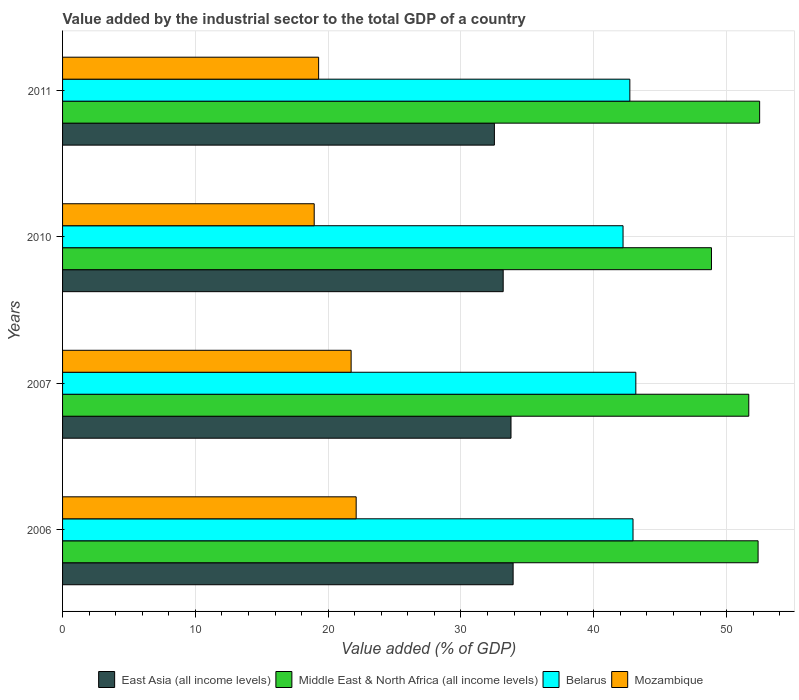How many different coloured bars are there?
Your response must be concise. 4. Are the number of bars per tick equal to the number of legend labels?
Your answer should be very brief. Yes. Are the number of bars on each tick of the Y-axis equal?
Make the answer very short. Yes. What is the label of the 1st group of bars from the top?
Keep it short and to the point. 2011. What is the value added by the industrial sector to the total GDP in Middle East & North Africa (all income levels) in 2010?
Keep it short and to the point. 48.86. Across all years, what is the maximum value added by the industrial sector to the total GDP in Middle East & North Africa (all income levels)?
Offer a terse response. 52.49. Across all years, what is the minimum value added by the industrial sector to the total GDP in Mozambique?
Make the answer very short. 18.95. What is the total value added by the industrial sector to the total GDP in Belarus in the graph?
Your answer should be compact. 171.04. What is the difference between the value added by the industrial sector to the total GDP in Belarus in 2006 and that in 2011?
Your response must be concise. 0.24. What is the difference between the value added by the industrial sector to the total GDP in Mozambique in 2010 and the value added by the industrial sector to the total GDP in Belarus in 2011?
Your answer should be compact. -23.77. What is the average value added by the industrial sector to the total GDP in Belarus per year?
Ensure brevity in your answer.  42.76. In the year 2007, what is the difference between the value added by the industrial sector to the total GDP in Middle East & North Africa (all income levels) and value added by the industrial sector to the total GDP in Mozambique?
Provide a succinct answer. 29.94. What is the ratio of the value added by the industrial sector to the total GDP in Belarus in 2010 to that in 2011?
Give a very brief answer. 0.99. Is the value added by the industrial sector to the total GDP in Belarus in 2007 less than that in 2010?
Offer a very short reply. No. What is the difference between the highest and the second highest value added by the industrial sector to the total GDP in East Asia (all income levels)?
Your response must be concise. 0.16. What is the difference between the highest and the lowest value added by the industrial sector to the total GDP in Mozambique?
Give a very brief answer. 3.16. Is the sum of the value added by the industrial sector to the total GDP in Belarus in 2007 and 2010 greater than the maximum value added by the industrial sector to the total GDP in East Asia (all income levels) across all years?
Offer a terse response. Yes. What does the 4th bar from the top in 2010 represents?
Ensure brevity in your answer.  East Asia (all income levels). What does the 1st bar from the bottom in 2011 represents?
Make the answer very short. East Asia (all income levels). Is it the case that in every year, the sum of the value added by the industrial sector to the total GDP in Mozambique and value added by the industrial sector to the total GDP in Middle East & North Africa (all income levels) is greater than the value added by the industrial sector to the total GDP in East Asia (all income levels)?
Your answer should be compact. Yes. How many bars are there?
Your answer should be compact. 16. How many years are there in the graph?
Your answer should be compact. 4. Are the values on the major ticks of X-axis written in scientific E-notation?
Your response must be concise. No. Does the graph contain grids?
Your response must be concise. Yes. Where does the legend appear in the graph?
Ensure brevity in your answer.  Bottom center. How are the legend labels stacked?
Your answer should be very brief. Horizontal. What is the title of the graph?
Offer a terse response. Value added by the industrial sector to the total GDP of a country. Does "Comoros" appear as one of the legend labels in the graph?
Your response must be concise. No. What is the label or title of the X-axis?
Your answer should be very brief. Value added (% of GDP). What is the Value added (% of GDP) of East Asia (all income levels) in 2006?
Provide a succinct answer. 33.93. What is the Value added (% of GDP) in Middle East & North Africa (all income levels) in 2006?
Your answer should be very brief. 52.37. What is the Value added (% of GDP) in Belarus in 2006?
Offer a very short reply. 42.95. What is the Value added (% of GDP) in Mozambique in 2006?
Your response must be concise. 22.11. What is the Value added (% of GDP) of East Asia (all income levels) in 2007?
Keep it short and to the point. 33.77. What is the Value added (% of GDP) of Middle East & North Africa (all income levels) in 2007?
Make the answer very short. 51.67. What is the Value added (% of GDP) in Belarus in 2007?
Make the answer very short. 43.17. What is the Value added (% of GDP) in Mozambique in 2007?
Your answer should be compact. 21.73. What is the Value added (% of GDP) in East Asia (all income levels) in 2010?
Provide a succinct answer. 33.18. What is the Value added (% of GDP) in Middle East & North Africa (all income levels) in 2010?
Keep it short and to the point. 48.86. What is the Value added (% of GDP) of Belarus in 2010?
Offer a terse response. 42.21. What is the Value added (% of GDP) of Mozambique in 2010?
Keep it short and to the point. 18.95. What is the Value added (% of GDP) of East Asia (all income levels) in 2011?
Make the answer very short. 32.52. What is the Value added (% of GDP) in Middle East & North Africa (all income levels) in 2011?
Ensure brevity in your answer.  52.49. What is the Value added (% of GDP) of Belarus in 2011?
Offer a very short reply. 42.72. What is the Value added (% of GDP) of Mozambique in 2011?
Your answer should be compact. 19.28. Across all years, what is the maximum Value added (% of GDP) in East Asia (all income levels)?
Your answer should be very brief. 33.93. Across all years, what is the maximum Value added (% of GDP) in Middle East & North Africa (all income levels)?
Provide a succinct answer. 52.49. Across all years, what is the maximum Value added (% of GDP) of Belarus?
Keep it short and to the point. 43.17. Across all years, what is the maximum Value added (% of GDP) of Mozambique?
Give a very brief answer. 22.11. Across all years, what is the minimum Value added (% of GDP) of East Asia (all income levels)?
Your answer should be compact. 32.52. Across all years, what is the minimum Value added (% of GDP) in Middle East & North Africa (all income levels)?
Give a very brief answer. 48.86. Across all years, what is the minimum Value added (% of GDP) of Belarus?
Provide a short and direct response. 42.21. Across all years, what is the minimum Value added (% of GDP) in Mozambique?
Make the answer very short. 18.95. What is the total Value added (% of GDP) in East Asia (all income levels) in the graph?
Offer a very short reply. 133.39. What is the total Value added (% of GDP) in Middle East & North Africa (all income levels) in the graph?
Provide a succinct answer. 205.4. What is the total Value added (% of GDP) in Belarus in the graph?
Give a very brief answer. 171.04. What is the total Value added (% of GDP) of Mozambique in the graph?
Offer a terse response. 82.07. What is the difference between the Value added (% of GDP) in East Asia (all income levels) in 2006 and that in 2007?
Offer a very short reply. 0.16. What is the difference between the Value added (% of GDP) in Middle East & North Africa (all income levels) in 2006 and that in 2007?
Ensure brevity in your answer.  0.7. What is the difference between the Value added (% of GDP) of Belarus in 2006 and that in 2007?
Your answer should be compact. -0.21. What is the difference between the Value added (% of GDP) in Mozambique in 2006 and that in 2007?
Offer a terse response. 0.38. What is the difference between the Value added (% of GDP) of East Asia (all income levels) in 2006 and that in 2010?
Keep it short and to the point. 0.75. What is the difference between the Value added (% of GDP) in Middle East & North Africa (all income levels) in 2006 and that in 2010?
Offer a terse response. 3.51. What is the difference between the Value added (% of GDP) in Belarus in 2006 and that in 2010?
Your answer should be compact. 0.75. What is the difference between the Value added (% of GDP) of Mozambique in 2006 and that in 2010?
Give a very brief answer. 3.16. What is the difference between the Value added (% of GDP) of East Asia (all income levels) in 2006 and that in 2011?
Give a very brief answer. 1.41. What is the difference between the Value added (% of GDP) of Middle East & North Africa (all income levels) in 2006 and that in 2011?
Your answer should be very brief. -0.12. What is the difference between the Value added (% of GDP) in Belarus in 2006 and that in 2011?
Your answer should be compact. 0.24. What is the difference between the Value added (% of GDP) in Mozambique in 2006 and that in 2011?
Make the answer very short. 2.83. What is the difference between the Value added (% of GDP) in East Asia (all income levels) in 2007 and that in 2010?
Your answer should be very brief. 0.59. What is the difference between the Value added (% of GDP) of Middle East & North Africa (all income levels) in 2007 and that in 2010?
Your answer should be compact. 2.81. What is the difference between the Value added (% of GDP) of Belarus in 2007 and that in 2010?
Give a very brief answer. 0.96. What is the difference between the Value added (% of GDP) in Mozambique in 2007 and that in 2010?
Offer a terse response. 2.78. What is the difference between the Value added (% of GDP) of East Asia (all income levels) in 2007 and that in 2011?
Make the answer very short. 1.25. What is the difference between the Value added (% of GDP) in Middle East & North Africa (all income levels) in 2007 and that in 2011?
Ensure brevity in your answer.  -0.82. What is the difference between the Value added (% of GDP) in Belarus in 2007 and that in 2011?
Give a very brief answer. 0.45. What is the difference between the Value added (% of GDP) of Mozambique in 2007 and that in 2011?
Provide a short and direct response. 2.45. What is the difference between the Value added (% of GDP) in East Asia (all income levels) in 2010 and that in 2011?
Your answer should be compact. 0.66. What is the difference between the Value added (% of GDP) of Middle East & North Africa (all income levels) in 2010 and that in 2011?
Give a very brief answer. -3.63. What is the difference between the Value added (% of GDP) of Belarus in 2010 and that in 2011?
Keep it short and to the point. -0.51. What is the difference between the Value added (% of GDP) of Mozambique in 2010 and that in 2011?
Keep it short and to the point. -0.33. What is the difference between the Value added (% of GDP) in East Asia (all income levels) in 2006 and the Value added (% of GDP) in Middle East & North Africa (all income levels) in 2007?
Make the answer very short. -17.75. What is the difference between the Value added (% of GDP) of East Asia (all income levels) in 2006 and the Value added (% of GDP) of Belarus in 2007?
Give a very brief answer. -9.24. What is the difference between the Value added (% of GDP) of East Asia (all income levels) in 2006 and the Value added (% of GDP) of Mozambique in 2007?
Provide a succinct answer. 12.2. What is the difference between the Value added (% of GDP) in Middle East & North Africa (all income levels) in 2006 and the Value added (% of GDP) in Belarus in 2007?
Your answer should be compact. 9.21. What is the difference between the Value added (% of GDP) of Middle East & North Africa (all income levels) in 2006 and the Value added (% of GDP) of Mozambique in 2007?
Your response must be concise. 30.65. What is the difference between the Value added (% of GDP) of Belarus in 2006 and the Value added (% of GDP) of Mozambique in 2007?
Give a very brief answer. 21.23. What is the difference between the Value added (% of GDP) in East Asia (all income levels) in 2006 and the Value added (% of GDP) in Middle East & North Africa (all income levels) in 2010?
Offer a very short reply. -14.94. What is the difference between the Value added (% of GDP) in East Asia (all income levels) in 2006 and the Value added (% of GDP) in Belarus in 2010?
Keep it short and to the point. -8.28. What is the difference between the Value added (% of GDP) in East Asia (all income levels) in 2006 and the Value added (% of GDP) in Mozambique in 2010?
Keep it short and to the point. 14.98. What is the difference between the Value added (% of GDP) of Middle East & North Africa (all income levels) in 2006 and the Value added (% of GDP) of Belarus in 2010?
Your answer should be compact. 10.17. What is the difference between the Value added (% of GDP) in Middle East & North Africa (all income levels) in 2006 and the Value added (% of GDP) in Mozambique in 2010?
Give a very brief answer. 33.43. What is the difference between the Value added (% of GDP) in Belarus in 2006 and the Value added (% of GDP) in Mozambique in 2010?
Provide a short and direct response. 24.01. What is the difference between the Value added (% of GDP) of East Asia (all income levels) in 2006 and the Value added (% of GDP) of Middle East & North Africa (all income levels) in 2011?
Give a very brief answer. -18.56. What is the difference between the Value added (% of GDP) in East Asia (all income levels) in 2006 and the Value added (% of GDP) in Belarus in 2011?
Provide a short and direct response. -8.79. What is the difference between the Value added (% of GDP) in East Asia (all income levels) in 2006 and the Value added (% of GDP) in Mozambique in 2011?
Make the answer very short. 14.65. What is the difference between the Value added (% of GDP) of Middle East & North Africa (all income levels) in 2006 and the Value added (% of GDP) of Belarus in 2011?
Offer a terse response. 9.66. What is the difference between the Value added (% of GDP) in Middle East & North Africa (all income levels) in 2006 and the Value added (% of GDP) in Mozambique in 2011?
Give a very brief answer. 33.09. What is the difference between the Value added (% of GDP) of Belarus in 2006 and the Value added (% of GDP) of Mozambique in 2011?
Provide a succinct answer. 23.67. What is the difference between the Value added (% of GDP) of East Asia (all income levels) in 2007 and the Value added (% of GDP) of Middle East & North Africa (all income levels) in 2010?
Provide a short and direct response. -15.09. What is the difference between the Value added (% of GDP) of East Asia (all income levels) in 2007 and the Value added (% of GDP) of Belarus in 2010?
Provide a succinct answer. -8.44. What is the difference between the Value added (% of GDP) in East Asia (all income levels) in 2007 and the Value added (% of GDP) in Mozambique in 2010?
Ensure brevity in your answer.  14.82. What is the difference between the Value added (% of GDP) of Middle East & North Africa (all income levels) in 2007 and the Value added (% of GDP) of Belarus in 2010?
Offer a terse response. 9.47. What is the difference between the Value added (% of GDP) in Middle East & North Africa (all income levels) in 2007 and the Value added (% of GDP) in Mozambique in 2010?
Give a very brief answer. 32.72. What is the difference between the Value added (% of GDP) in Belarus in 2007 and the Value added (% of GDP) in Mozambique in 2010?
Offer a terse response. 24.22. What is the difference between the Value added (% of GDP) of East Asia (all income levels) in 2007 and the Value added (% of GDP) of Middle East & North Africa (all income levels) in 2011?
Offer a terse response. -18.72. What is the difference between the Value added (% of GDP) of East Asia (all income levels) in 2007 and the Value added (% of GDP) of Belarus in 2011?
Your answer should be compact. -8.95. What is the difference between the Value added (% of GDP) of East Asia (all income levels) in 2007 and the Value added (% of GDP) of Mozambique in 2011?
Keep it short and to the point. 14.49. What is the difference between the Value added (% of GDP) in Middle East & North Africa (all income levels) in 2007 and the Value added (% of GDP) in Belarus in 2011?
Your answer should be very brief. 8.96. What is the difference between the Value added (% of GDP) in Middle East & North Africa (all income levels) in 2007 and the Value added (% of GDP) in Mozambique in 2011?
Give a very brief answer. 32.39. What is the difference between the Value added (% of GDP) in Belarus in 2007 and the Value added (% of GDP) in Mozambique in 2011?
Ensure brevity in your answer.  23.89. What is the difference between the Value added (% of GDP) in East Asia (all income levels) in 2010 and the Value added (% of GDP) in Middle East & North Africa (all income levels) in 2011?
Offer a terse response. -19.31. What is the difference between the Value added (% of GDP) in East Asia (all income levels) in 2010 and the Value added (% of GDP) in Belarus in 2011?
Offer a terse response. -9.54. What is the difference between the Value added (% of GDP) of East Asia (all income levels) in 2010 and the Value added (% of GDP) of Mozambique in 2011?
Provide a short and direct response. 13.9. What is the difference between the Value added (% of GDP) of Middle East & North Africa (all income levels) in 2010 and the Value added (% of GDP) of Belarus in 2011?
Make the answer very short. 6.15. What is the difference between the Value added (% of GDP) in Middle East & North Africa (all income levels) in 2010 and the Value added (% of GDP) in Mozambique in 2011?
Make the answer very short. 29.58. What is the difference between the Value added (% of GDP) in Belarus in 2010 and the Value added (% of GDP) in Mozambique in 2011?
Your response must be concise. 22.92. What is the average Value added (% of GDP) in East Asia (all income levels) per year?
Give a very brief answer. 33.35. What is the average Value added (% of GDP) of Middle East & North Africa (all income levels) per year?
Offer a very short reply. 51.35. What is the average Value added (% of GDP) of Belarus per year?
Keep it short and to the point. 42.76. What is the average Value added (% of GDP) of Mozambique per year?
Your response must be concise. 20.52. In the year 2006, what is the difference between the Value added (% of GDP) in East Asia (all income levels) and Value added (% of GDP) in Middle East & North Africa (all income levels)?
Keep it short and to the point. -18.45. In the year 2006, what is the difference between the Value added (% of GDP) of East Asia (all income levels) and Value added (% of GDP) of Belarus?
Provide a succinct answer. -9.03. In the year 2006, what is the difference between the Value added (% of GDP) in East Asia (all income levels) and Value added (% of GDP) in Mozambique?
Make the answer very short. 11.82. In the year 2006, what is the difference between the Value added (% of GDP) of Middle East & North Africa (all income levels) and Value added (% of GDP) of Belarus?
Your answer should be very brief. 9.42. In the year 2006, what is the difference between the Value added (% of GDP) in Middle East & North Africa (all income levels) and Value added (% of GDP) in Mozambique?
Your answer should be compact. 30.27. In the year 2006, what is the difference between the Value added (% of GDP) in Belarus and Value added (% of GDP) in Mozambique?
Your answer should be very brief. 20.85. In the year 2007, what is the difference between the Value added (% of GDP) in East Asia (all income levels) and Value added (% of GDP) in Middle East & North Africa (all income levels)?
Keep it short and to the point. -17.91. In the year 2007, what is the difference between the Value added (% of GDP) of East Asia (all income levels) and Value added (% of GDP) of Belarus?
Offer a very short reply. -9.4. In the year 2007, what is the difference between the Value added (% of GDP) in East Asia (all income levels) and Value added (% of GDP) in Mozambique?
Provide a short and direct response. 12.04. In the year 2007, what is the difference between the Value added (% of GDP) of Middle East & North Africa (all income levels) and Value added (% of GDP) of Belarus?
Ensure brevity in your answer.  8.51. In the year 2007, what is the difference between the Value added (% of GDP) of Middle East & North Africa (all income levels) and Value added (% of GDP) of Mozambique?
Make the answer very short. 29.94. In the year 2007, what is the difference between the Value added (% of GDP) of Belarus and Value added (% of GDP) of Mozambique?
Your answer should be compact. 21.44. In the year 2010, what is the difference between the Value added (% of GDP) in East Asia (all income levels) and Value added (% of GDP) in Middle East & North Africa (all income levels)?
Make the answer very short. -15.68. In the year 2010, what is the difference between the Value added (% of GDP) of East Asia (all income levels) and Value added (% of GDP) of Belarus?
Offer a terse response. -9.03. In the year 2010, what is the difference between the Value added (% of GDP) in East Asia (all income levels) and Value added (% of GDP) in Mozambique?
Provide a succinct answer. 14.23. In the year 2010, what is the difference between the Value added (% of GDP) of Middle East & North Africa (all income levels) and Value added (% of GDP) of Belarus?
Give a very brief answer. 6.66. In the year 2010, what is the difference between the Value added (% of GDP) of Middle East & North Africa (all income levels) and Value added (% of GDP) of Mozambique?
Offer a terse response. 29.91. In the year 2010, what is the difference between the Value added (% of GDP) of Belarus and Value added (% of GDP) of Mozambique?
Provide a short and direct response. 23.26. In the year 2011, what is the difference between the Value added (% of GDP) of East Asia (all income levels) and Value added (% of GDP) of Middle East & North Africa (all income levels)?
Keep it short and to the point. -19.97. In the year 2011, what is the difference between the Value added (% of GDP) in East Asia (all income levels) and Value added (% of GDP) in Belarus?
Your answer should be compact. -10.2. In the year 2011, what is the difference between the Value added (% of GDP) in East Asia (all income levels) and Value added (% of GDP) in Mozambique?
Provide a succinct answer. 13.24. In the year 2011, what is the difference between the Value added (% of GDP) in Middle East & North Africa (all income levels) and Value added (% of GDP) in Belarus?
Offer a very short reply. 9.77. In the year 2011, what is the difference between the Value added (% of GDP) in Middle East & North Africa (all income levels) and Value added (% of GDP) in Mozambique?
Offer a very short reply. 33.21. In the year 2011, what is the difference between the Value added (% of GDP) in Belarus and Value added (% of GDP) in Mozambique?
Your answer should be compact. 23.44. What is the ratio of the Value added (% of GDP) of Middle East & North Africa (all income levels) in 2006 to that in 2007?
Make the answer very short. 1.01. What is the ratio of the Value added (% of GDP) in Mozambique in 2006 to that in 2007?
Offer a very short reply. 1.02. What is the ratio of the Value added (% of GDP) of East Asia (all income levels) in 2006 to that in 2010?
Offer a terse response. 1.02. What is the ratio of the Value added (% of GDP) in Middle East & North Africa (all income levels) in 2006 to that in 2010?
Offer a terse response. 1.07. What is the ratio of the Value added (% of GDP) of Belarus in 2006 to that in 2010?
Provide a short and direct response. 1.02. What is the ratio of the Value added (% of GDP) in Mozambique in 2006 to that in 2010?
Keep it short and to the point. 1.17. What is the ratio of the Value added (% of GDP) of East Asia (all income levels) in 2006 to that in 2011?
Offer a very short reply. 1.04. What is the ratio of the Value added (% of GDP) of Middle East & North Africa (all income levels) in 2006 to that in 2011?
Offer a terse response. 1. What is the ratio of the Value added (% of GDP) of Belarus in 2006 to that in 2011?
Your response must be concise. 1.01. What is the ratio of the Value added (% of GDP) of Mozambique in 2006 to that in 2011?
Keep it short and to the point. 1.15. What is the ratio of the Value added (% of GDP) of East Asia (all income levels) in 2007 to that in 2010?
Your response must be concise. 1.02. What is the ratio of the Value added (% of GDP) in Middle East & North Africa (all income levels) in 2007 to that in 2010?
Offer a very short reply. 1.06. What is the ratio of the Value added (% of GDP) in Belarus in 2007 to that in 2010?
Your response must be concise. 1.02. What is the ratio of the Value added (% of GDP) of Mozambique in 2007 to that in 2010?
Your answer should be very brief. 1.15. What is the ratio of the Value added (% of GDP) of East Asia (all income levels) in 2007 to that in 2011?
Ensure brevity in your answer.  1.04. What is the ratio of the Value added (% of GDP) in Middle East & North Africa (all income levels) in 2007 to that in 2011?
Keep it short and to the point. 0.98. What is the ratio of the Value added (% of GDP) of Belarus in 2007 to that in 2011?
Keep it short and to the point. 1.01. What is the ratio of the Value added (% of GDP) of Mozambique in 2007 to that in 2011?
Provide a succinct answer. 1.13. What is the ratio of the Value added (% of GDP) of East Asia (all income levels) in 2010 to that in 2011?
Keep it short and to the point. 1.02. What is the ratio of the Value added (% of GDP) in Middle East & North Africa (all income levels) in 2010 to that in 2011?
Provide a succinct answer. 0.93. What is the ratio of the Value added (% of GDP) in Mozambique in 2010 to that in 2011?
Provide a succinct answer. 0.98. What is the difference between the highest and the second highest Value added (% of GDP) of East Asia (all income levels)?
Your answer should be very brief. 0.16. What is the difference between the highest and the second highest Value added (% of GDP) in Middle East & North Africa (all income levels)?
Make the answer very short. 0.12. What is the difference between the highest and the second highest Value added (% of GDP) of Belarus?
Offer a terse response. 0.21. What is the difference between the highest and the second highest Value added (% of GDP) in Mozambique?
Your answer should be very brief. 0.38. What is the difference between the highest and the lowest Value added (% of GDP) in East Asia (all income levels)?
Provide a succinct answer. 1.41. What is the difference between the highest and the lowest Value added (% of GDP) of Middle East & North Africa (all income levels)?
Your answer should be compact. 3.63. What is the difference between the highest and the lowest Value added (% of GDP) of Belarus?
Provide a short and direct response. 0.96. What is the difference between the highest and the lowest Value added (% of GDP) of Mozambique?
Your answer should be very brief. 3.16. 